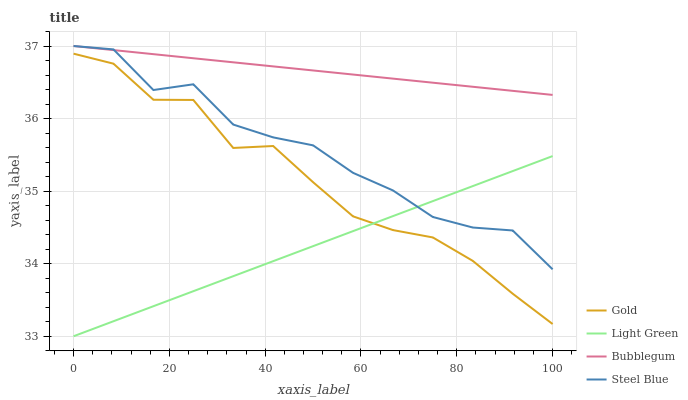Does Gold have the minimum area under the curve?
Answer yes or no. No. Does Gold have the maximum area under the curve?
Answer yes or no. No. Is Light Green the smoothest?
Answer yes or no. No. Is Light Green the roughest?
Answer yes or no. No. Does Gold have the lowest value?
Answer yes or no. No. Does Gold have the highest value?
Answer yes or no. No. Is Gold less than Steel Blue?
Answer yes or no. Yes. Is Bubblegum greater than Gold?
Answer yes or no. Yes. Does Gold intersect Steel Blue?
Answer yes or no. No. 